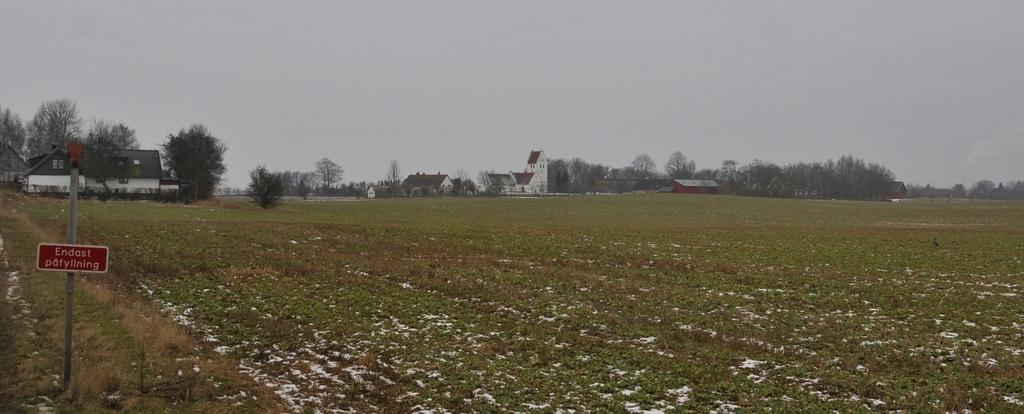What is the main setting of the image? There is a field in the image. What can be seen in the background of the field? There are trees and houses in the background of the image. How would you describe the weather in the image? The sky is cloudy in the image. Is there a baseball game taking place in the field in the image? There is no indication of a baseball game or any sports activity in the image. 